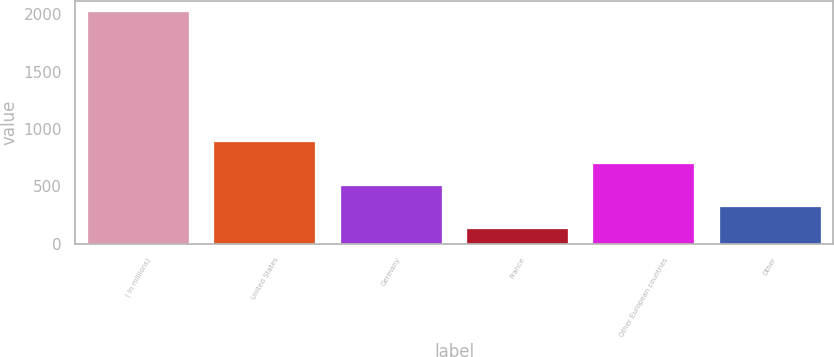Convert chart to OTSL. <chart><loc_0><loc_0><loc_500><loc_500><bar_chart><fcel>( in millions)<fcel>United States<fcel>Germany<fcel>France<fcel>Other European countries<fcel>Other<nl><fcel>2018<fcel>883.7<fcel>505.6<fcel>127.5<fcel>694.65<fcel>316.55<nl></chart> 